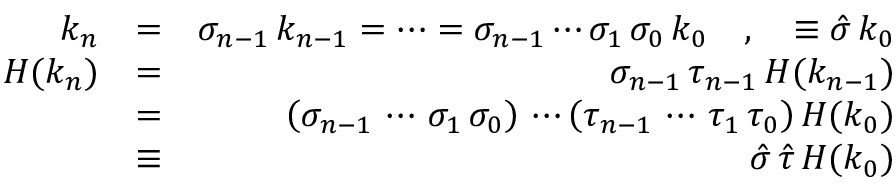Convert formula to latex. <formula><loc_0><loc_0><loc_500><loc_500>\begin{array} { r l r } { k _ { n } } & { = } & { \sigma _ { n - 1 } \, k _ { n - 1 } = \cdots = \sigma _ { n - 1 } \cdots \sigma _ { 1 } \, \sigma _ { 0 } \, k _ { 0 } \quad , \quad \equiv \hat { \sigma } \, k _ { 0 } } \\ { H ( k _ { n } ) } & { = } & { \sigma _ { n - 1 } \, \tau _ { n - 1 } \, H ( k _ { n - 1 } ) } \\ & { = } & { \left ( \sigma _ { n - 1 } \, \cdots \, \sigma _ { 1 } \, \sigma _ { 0 } \right ) \, \cdots \left ( \tau _ { n - 1 } \, \cdots \, \tau _ { 1 } \, \tau _ { 0 } \right ) H ( k _ { 0 } ) } \\ & { \equiv } & { \hat { \sigma } \, \hat { \tau } \, H ( k _ { 0 } ) } \end{array}</formula> 